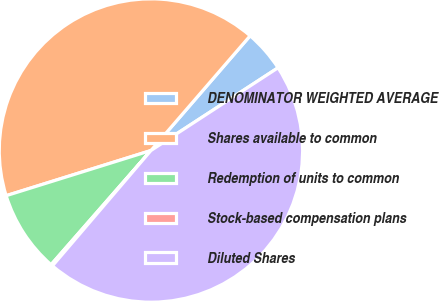Convert chart. <chart><loc_0><loc_0><loc_500><loc_500><pie_chart><fcel>DENOMINATOR WEIGHTED AVERAGE<fcel>Shares available to common<fcel>Redemption of units to common<fcel>Stock-based compensation plans<fcel>Diluted Shares<nl><fcel>4.47%<fcel>41.16%<fcel>8.75%<fcel>0.19%<fcel>45.44%<nl></chart> 